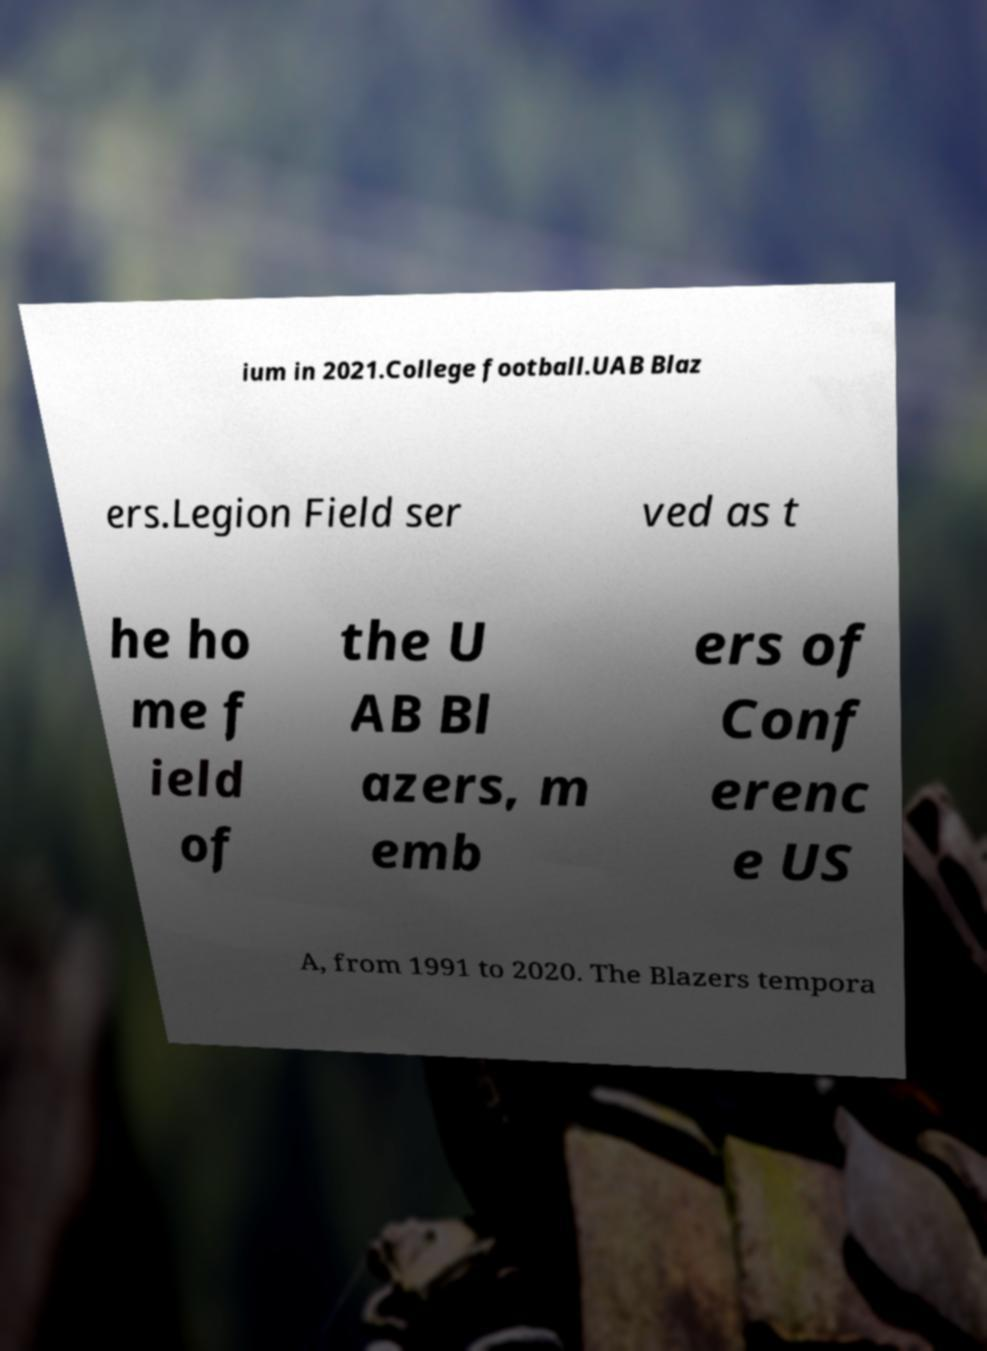Could you assist in decoding the text presented in this image and type it out clearly? ium in 2021.College football.UAB Blaz ers.Legion Field ser ved as t he ho me f ield of the U AB Bl azers, m emb ers of Conf erenc e US A, from 1991 to 2020. The Blazers tempora 